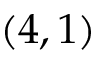<formula> <loc_0><loc_0><loc_500><loc_500>( 4 , 1 )</formula> 